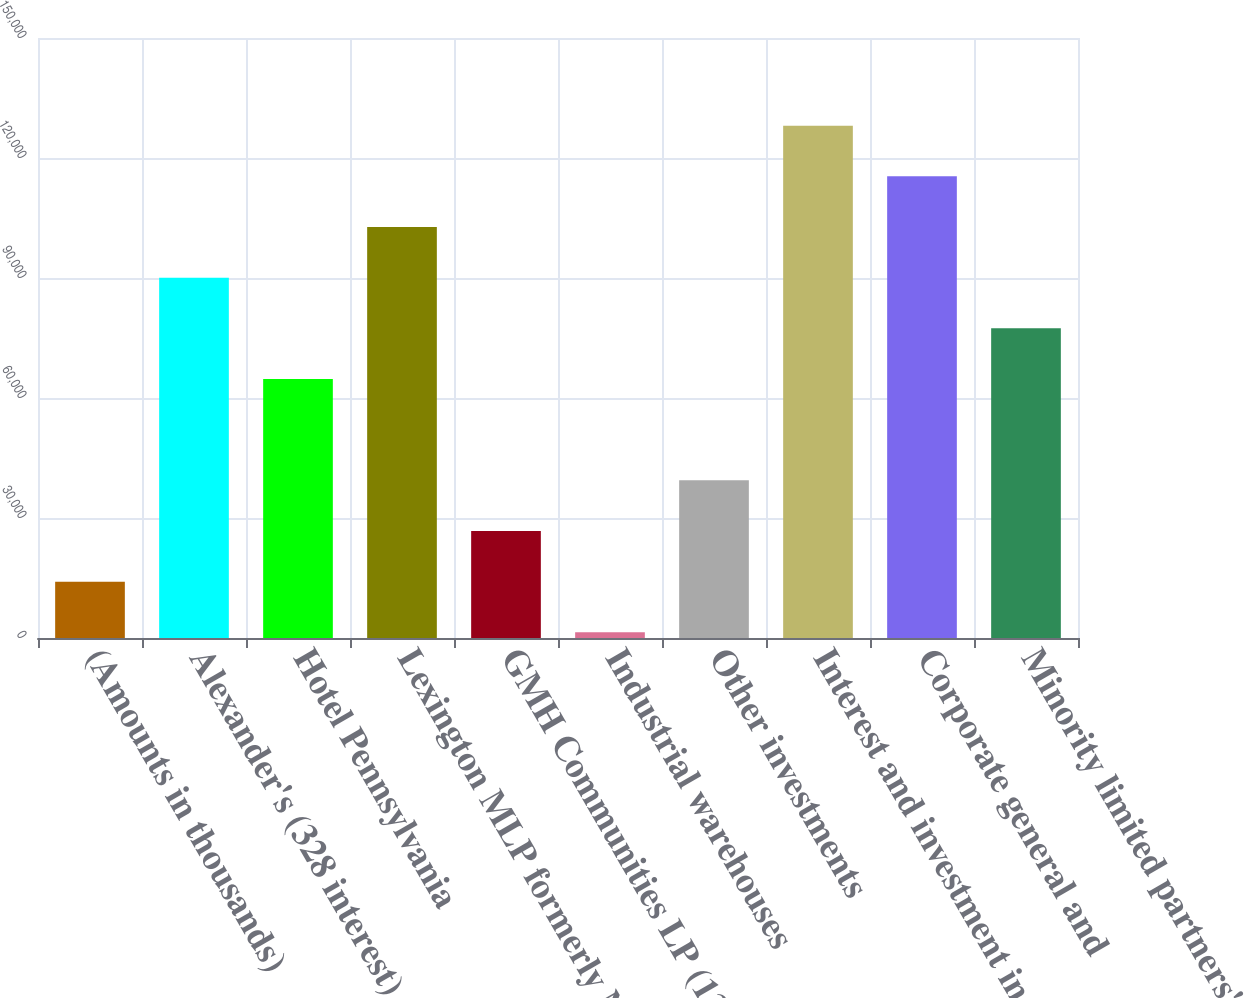Convert chart to OTSL. <chart><loc_0><loc_0><loc_500><loc_500><bar_chart><fcel>(Amounts in thousands)<fcel>Alexander's (328 interest)<fcel>Hotel Pennsylvania<fcel>Lexington MLP formerly Newkirk<fcel>GMH Communities LP (138<fcel>Industrial warehouses<fcel>Other investments<fcel>Interest and investment income<fcel>Corporate general and<fcel>Minority limited partners'<nl><fcel>14081.5<fcel>90080.5<fcel>64747.5<fcel>102747<fcel>26748<fcel>1415<fcel>39414.5<fcel>128080<fcel>115414<fcel>77414<nl></chart> 